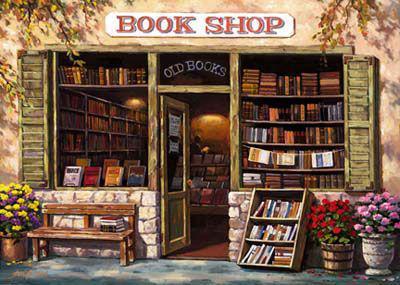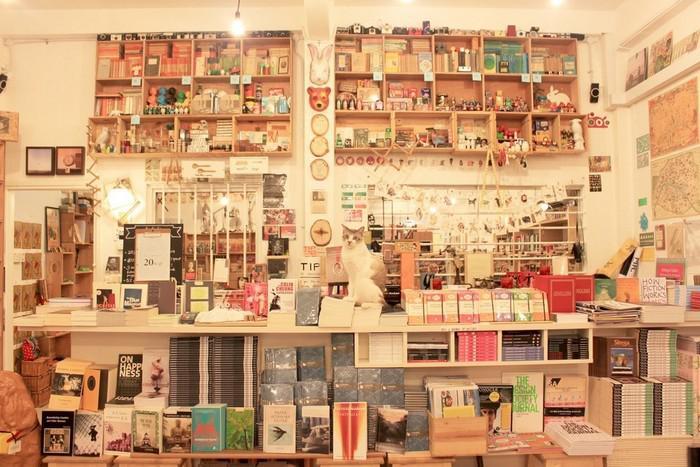The first image is the image on the left, the second image is the image on the right. Analyze the images presented: Is the assertion "A form of seating is shown outside of a bookstore." valid? Answer yes or no. Yes. The first image is the image on the left, the second image is the image on the right. Evaluate the accuracy of this statement regarding the images: "The exterior of a book shop includes some type of outdoor seating furniture.". Is it true? Answer yes or no. Yes. 